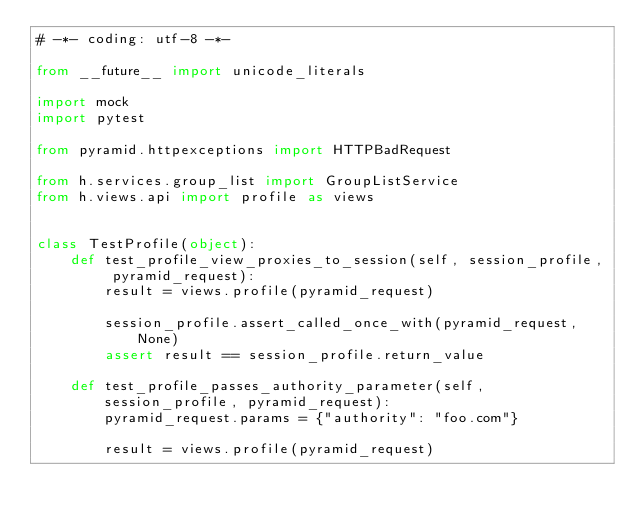<code> <loc_0><loc_0><loc_500><loc_500><_Python_># -*- coding: utf-8 -*-

from __future__ import unicode_literals

import mock
import pytest

from pyramid.httpexceptions import HTTPBadRequest

from h.services.group_list import GroupListService
from h.views.api import profile as views


class TestProfile(object):
    def test_profile_view_proxies_to_session(self, session_profile, pyramid_request):
        result = views.profile(pyramid_request)

        session_profile.assert_called_once_with(pyramid_request, None)
        assert result == session_profile.return_value

    def test_profile_passes_authority_parameter(self, session_profile, pyramid_request):
        pyramid_request.params = {"authority": "foo.com"}

        result = views.profile(pyramid_request)
</code> 